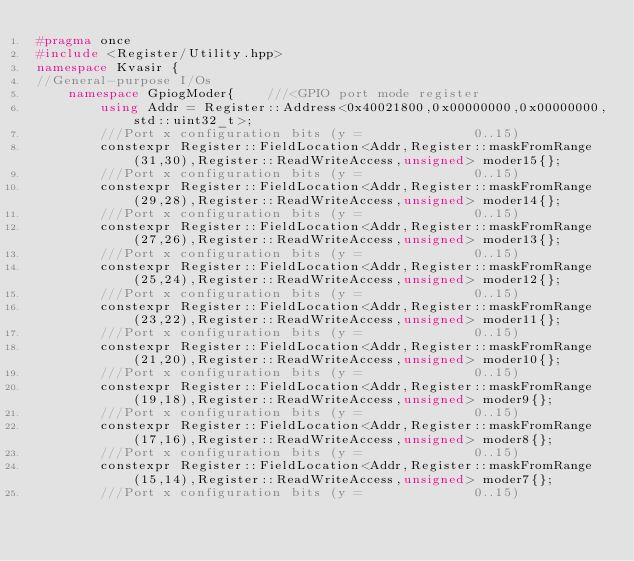<code> <loc_0><loc_0><loc_500><loc_500><_C++_>#pragma once 
#include <Register/Utility.hpp>
namespace Kvasir {
//General-purpose I/Os
    namespace GpiogModer{    ///<GPIO port mode register
        using Addr = Register::Address<0x40021800,0x00000000,0x00000000,std::uint32_t>;
        ///Port x configuration bits (y =              0..15)
        constexpr Register::FieldLocation<Addr,Register::maskFromRange(31,30),Register::ReadWriteAccess,unsigned> moder15{}; 
        ///Port x configuration bits (y =              0..15)
        constexpr Register::FieldLocation<Addr,Register::maskFromRange(29,28),Register::ReadWriteAccess,unsigned> moder14{}; 
        ///Port x configuration bits (y =              0..15)
        constexpr Register::FieldLocation<Addr,Register::maskFromRange(27,26),Register::ReadWriteAccess,unsigned> moder13{}; 
        ///Port x configuration bits (y =              0..15)
        constexpr Register::FieldLocation<Addr,Register::maskFromRange(25,24),Register::ReadWriteAccess,unsigned> moder12{}; 
        ///Port x configuration bits (y =              0..15)
        constexpr Register::FieldLocation<Addr,Register::maskFromRange(23,22),Register::ReadWriteAccess,unsigned> moder11{}; 
        ///Port x configuration bits (y =              0..15)
        constexpr Register::FieldLocation<Addr,Register::maskFromRange(21,20),Register::ReadWriteAccess,unsigned> moder10{}; 
        ///Port x configuration bits (y =              0..15)
        constexpr Register::FieldLocation<Addr,Register::maskFromRange(19,18),Register::ReadWriteAccess,unsigned> moder9{}; 
        ///Port x configuration bits (y =              0..15)
        constexpr Register::FieldLocation<Addr,Register::maskFromRange(17,16),Register::ReadWriteAccess,unsigned> moder8{}; 
        ///Port x configuration bits (y =              0..15)
        constexpr Register::FieldLocation<Addr,Register::maskFromRange(15,14),Register::ReadWriteAccess,unsigned> moder7{}; 
        ///Port x configuration bits (y =              0..15)</code> 